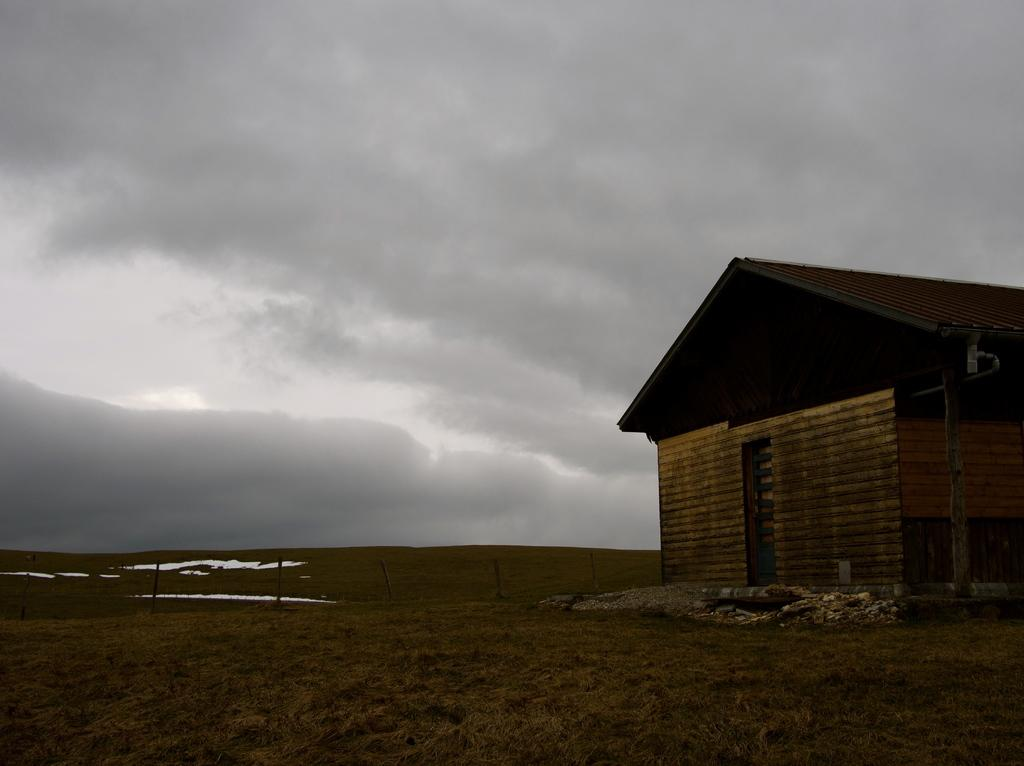What structure is located on the right side of the image? There is a house on the right side of the image. What type of vegetation is at the bottom of the image? There is grass at the bottom of the image. What is visible at the top of the image? The sky is visible at the top of the image. What can be seen in the sky in the image? Clouds are present in the sky. What number is being used in the science experiment depicted in the image? There is no science experiment or number present in the image. How many times should the paper be folded to reach the moon in the image? There is no paper or moon depicted in the image, so it is not possible to answer that question. 